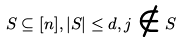<formula> <loc_0><loc_0><loc_500><loc_500>S \subseteq [ n ] , | S | \leq d , j \notin S</formula> 